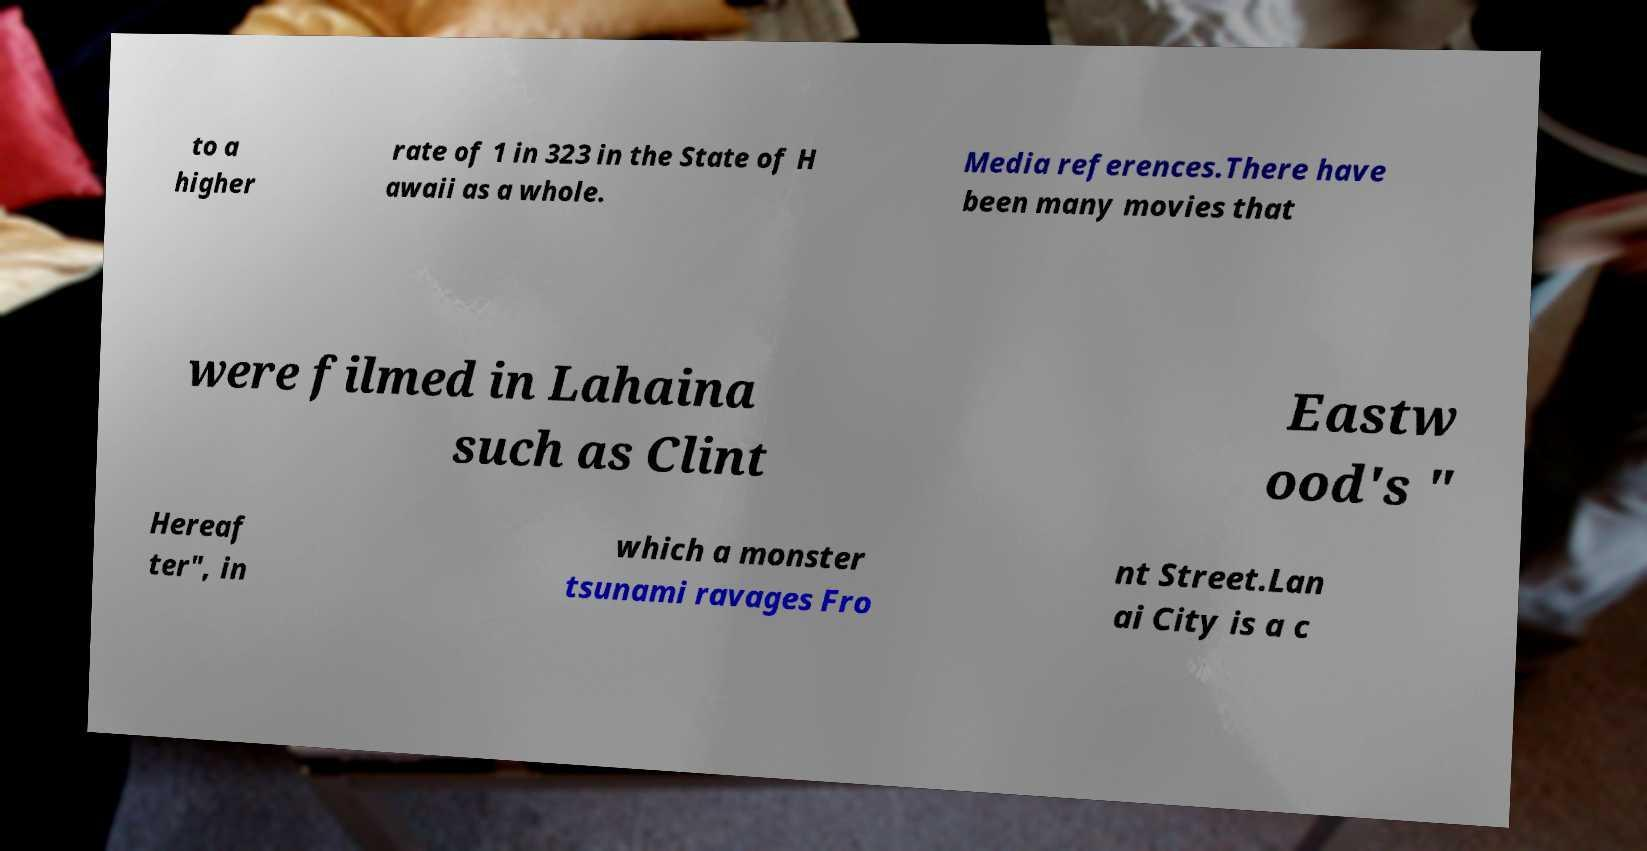Can you read and provide the text displayed in the image?This photo seems to have some interesting text. Can you extract and type it out for me? to a higher rate of 1 in 323 in the State of H awaii as a whole. Media references.There have been many movies that were filmed in Lahaina such as Clint Eastw ood's " Hereaf ter", in which a monster tsunami ravages Fro nt Street.Lan ai City is a c 